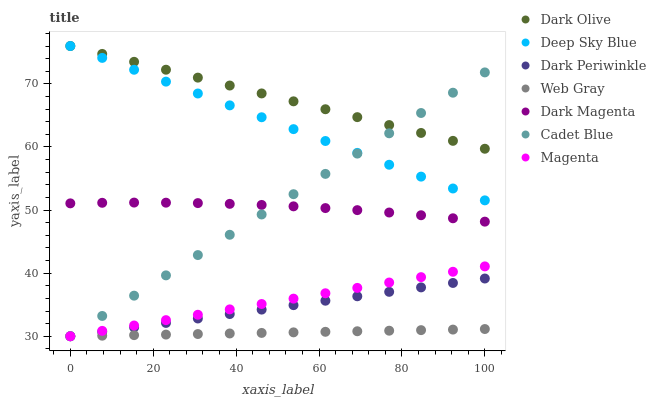Does Web Gray have the minimum area under the curve?
Answer yes or no. Yes. Does Dark Olive have the maximum area under the curve?
Answer yes or no. Yes. Does Dark Magenta have the minimum area under the curve?
Answer yes or no. No. Does Dark Magenta have the maximum area under the curve?
Answer yes or no. No. Is Dark Periwinkle the smoothest?
Answer yes or no. Yes. Is Dark Magenta the roughest?
Answer yes or no. Yes. Is Dark Olive the smoothest?
Answer yes or no. No. Is Dark Olive the roughest?
Answer yes or no. No. Does Cadet Blue have the lowest value?
Answer yes or no. Yes. Does Dark Magenta have the lowest value?
Answer yes or no. No. Does Deep Sky Blue have the highest value?
Answer yes or no. Yes. Does Dark Magenta have the highest value?
Answer yes or no. No. Is Magenta less than Dark Magenta?
Answer yes or no. Yes. Is Deep Sky Blue greater than Dark Periwinkle?
Answer yes or no. Yes. Does Magenta intersect Web Gray?
Answer yes or no. Yes. Is Magenta less than Web Gray?
Answer yes or no. No. Is Magenta greater than Web Gray?
Answer yes or no. No. Does Magenta intersect Dark Magenta?
Answer yes or no. No. 